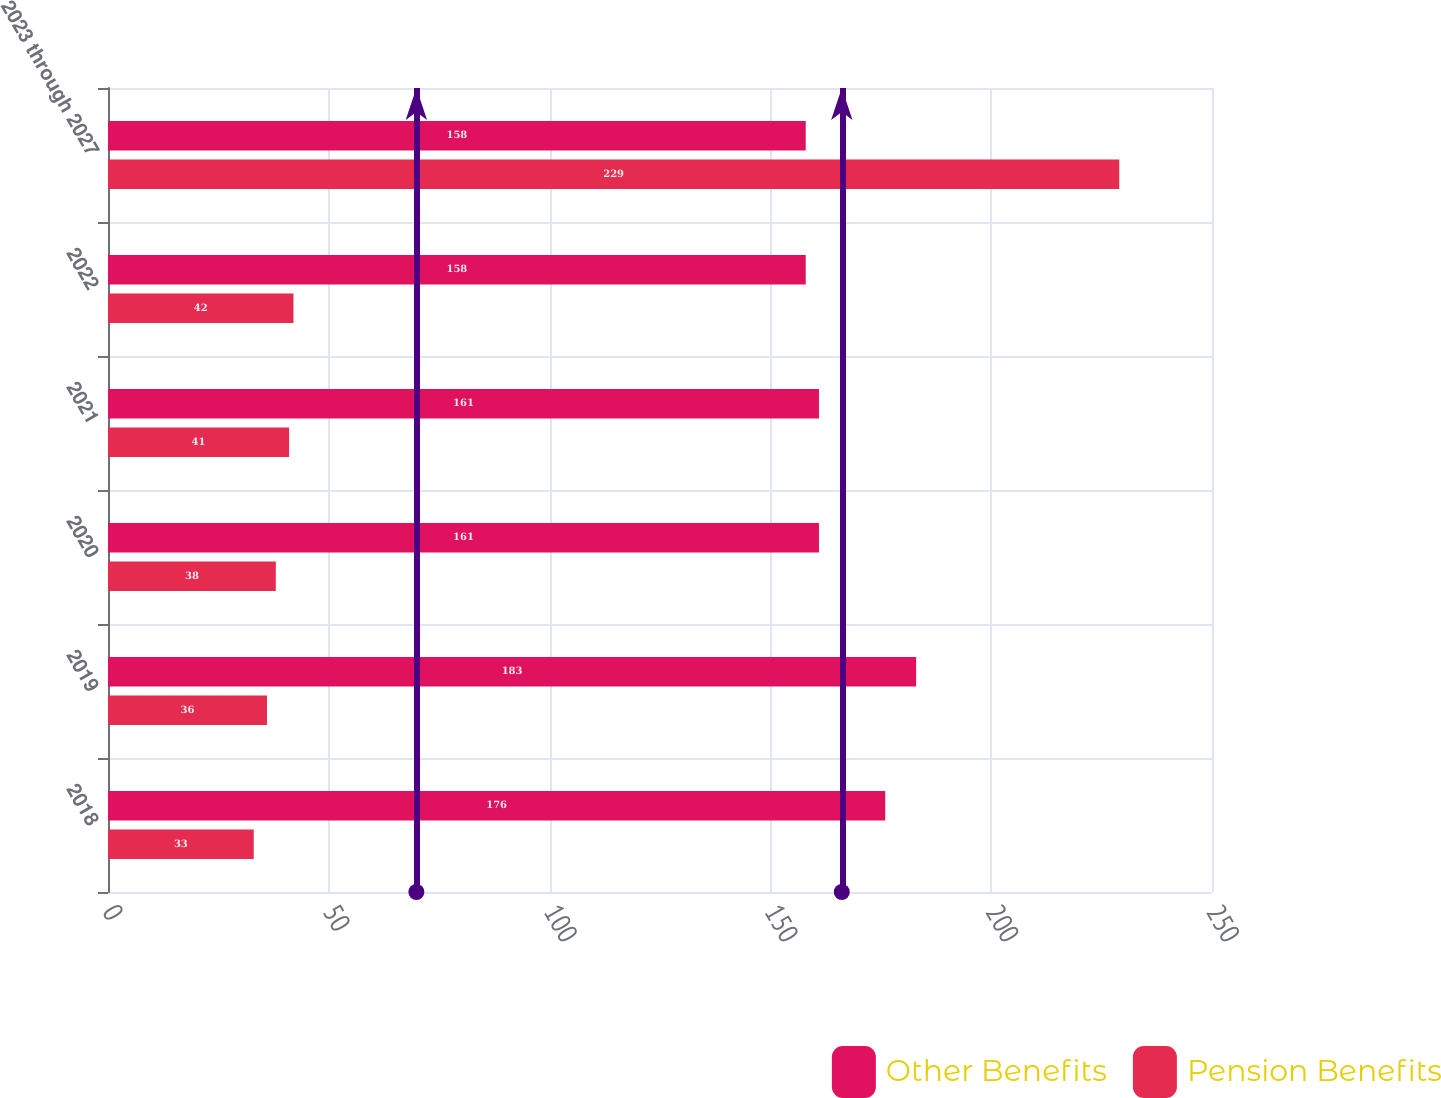<chart> <loc_0><loc_0><loc_500><loc_500><stacked_bar_chart><ecel><fcel>2018<fcel>2019<fcel>2020<fcel>2021<fcel>2022<fcel>2023 through 2027<nl><fcel>Other Benefits<fcel>176<fcel>183<fcel>161<fcel>161<fcel>158<fcel>158<nl><fcel>Pension Benefits<fcel>33<fcel>36<fcel>38<fcel>41<fcel>42<fcel>229<nl></chart> 